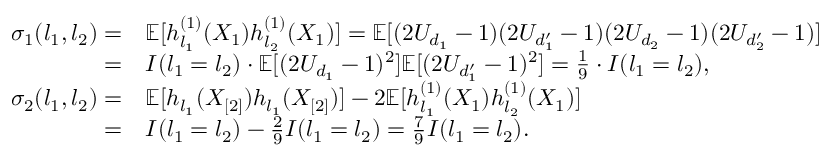Convert formula to latex. <formula><loc_0><loc_0><loc_500><loc_500>\begin{array} { r l } { \sigma _ { 1 } ( l _ { 1 } , l _ { 2 } ) = } & { \mathbb { E } [ h _ { l _ { 1 } } ^ { ( 1 ) } ( X _ { 1 } ) h _ { l _ { 2 } } ^ { ( 1 ) } ( X _ { 1 } ) ] = \mathbb { E } [ ( 2 U _ { d _ { 1 } } - 1 ) ( 2 U _ { d _ { 1 } ^ { \prime } } - 1 ) ( 2 U _ { d _ { 2 } } - 1 ) ( 2 U _ { d _ { 2 } ^ { \prime } } - 1 ) ] } \\ { = } & { I ( l _ { 1 } = l _ { 2 } ) \cdot \mathbb { E } [ ( 2 U _ { d _ { 1 } } - 1 ) ^ { 2 } ] \mathbb { E } [ ( 2 U _ { d _ { 1 } ^ { \prime } } - 1 ) ^ { 2 } ] = \frac { 1 } { 9 } \cdot I ( l _ { 1 } = l _ { 2 } ) , } \\ { \sigma _ { 2 } ( l _ { 1 } , l _ { 2 } ) = } & { \mathbb { E } [ h _ { l _ { 1 } } ( X _ { [ 2 ] } ) h _ { l _ { 1 } } ( X _ { [ 2 ] } ) ] - 2 \mathbb { E } [ h _ { l _ { 1 } } ^ { ( 1 ) } ( X _ { 1 } ) h _ { l _ { 2 } } ^ { ( 1 ) } ( X _ { 1 } ) ] } \\ { = } & { I ( l _ { 1 } = l _ { 2 } ) - \frac { 2 } { 9 } I ( l _ { 1 } = l _ { 2 } ) = \frac { 7 } { 9 } I ( l _ { 1 } = l _ { 2 } ) . } \end{array}</formula> 